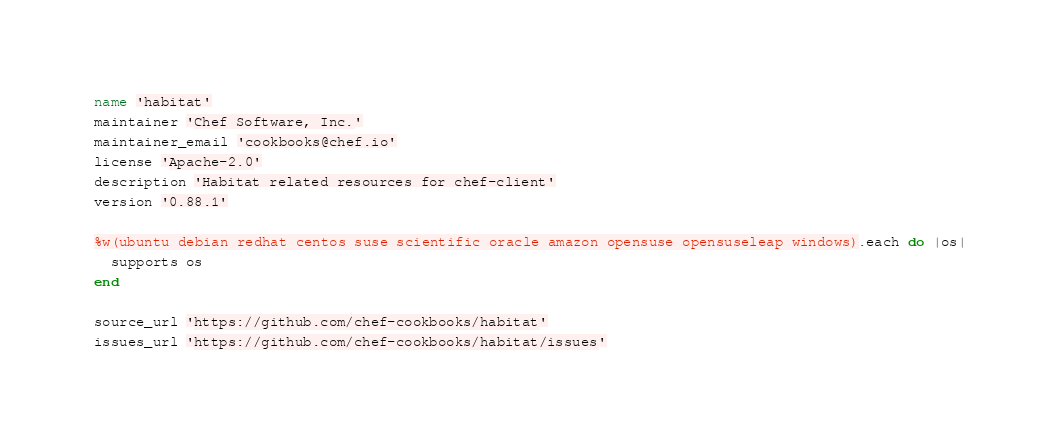Convert code to text. <code><loc_0><loc_0><loc_500><loc_500><_Ruby_>name 'habitat'
maintainer 'Chef Software, Inc.'
maintainer_email 'cookbooks@chef.io'
license 'Apache-2.0'
description 'Habitat related resources for chef-client'
version '0.88.1'

%w(ubuntu debian redhat centos suse scientific oracle amazon opensuse opensuseleap windows).each do |os|
  supports os
end

source_url 'https://github.com/chef-cookbooks/habitat'
issues_url 'https://github.com/chef-cookbooks/habitat/issues'
</code> 